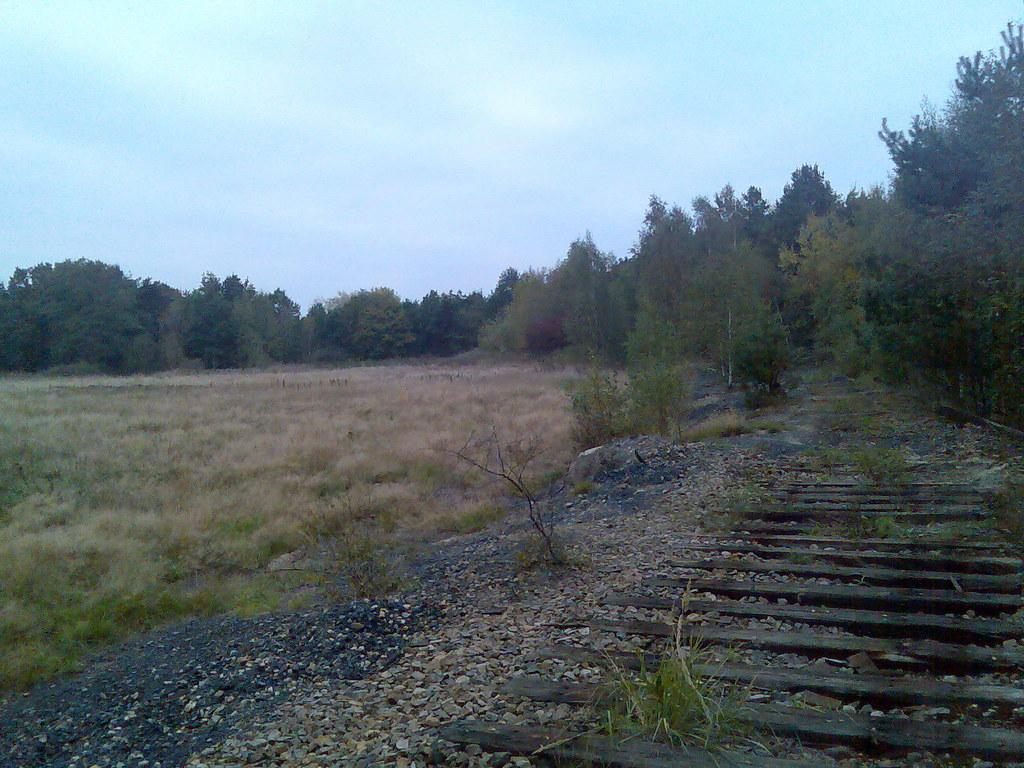What type of natural elements can be seen in the image? There are stones, trees, plants, wooden sticks, and grass visible in the image. What is the background of the image? The sky is visible in the background of the image. What invention can be seen in the image during the rainstorm? There is no rainstorm or invention present in the image; it features natural elements such as stones, trees, plants, wooden sticks, and grass. 